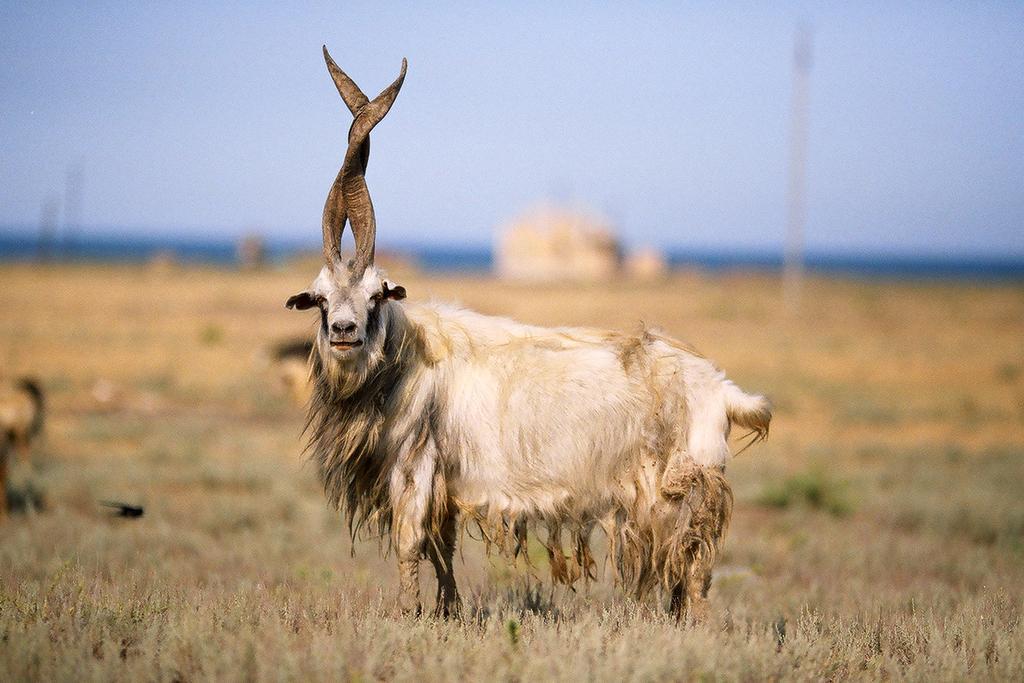In one or two sentences, can you explain what this image depicts? In this image I can see a animal which is black, white and brown in color is standing on the ground. I can see some grass. In the background I can see the sky and few other blurry objects. 